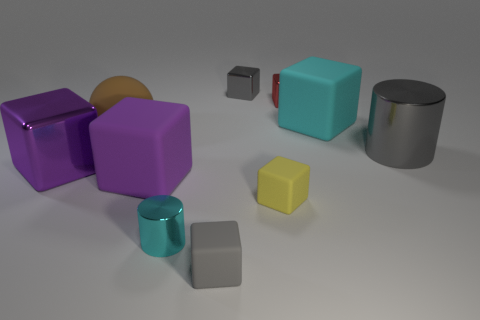How many big things are brown objects or gray metal objects?
Offer a very short reply. 2. Is there any other thing of the same color as the large shiny cylinder?
Give a very brief answer. Yes. Are there any red objects right of the big purple matte object?
Your answer should be very brief. Yes. What size is the cyan thing on the right side of the small gray cube behind the tiny gray matte block?
Provide a short and direct response. Large. Is the number of yellow cubes that are behind the purple metallic object the same as the number of rubber blocks in front of the brown rubber thing?
Make the answer very short. No. Is there a cyan cylinder that is left of the tiny gray cube to the right of the gray rubber thing?
Offer a very short reply. Yes. There is a cylinder in front of the metal block that is in front of the large cyan rubber object; how many large brown rubber objects are to the left of it?
Your answer should be compact. 1. Is the number of big purple metal objects less than the number of tiny brown matte cubes?
Offer a terse response. No. Is the shape of the big metal object that is right of the cyan metallic thing the same as the matte object that is in front of the tiny cyan metal cylinder?
Keep it short and to the point. No. The sphere is what color?
Your response must be concise. Brown. 